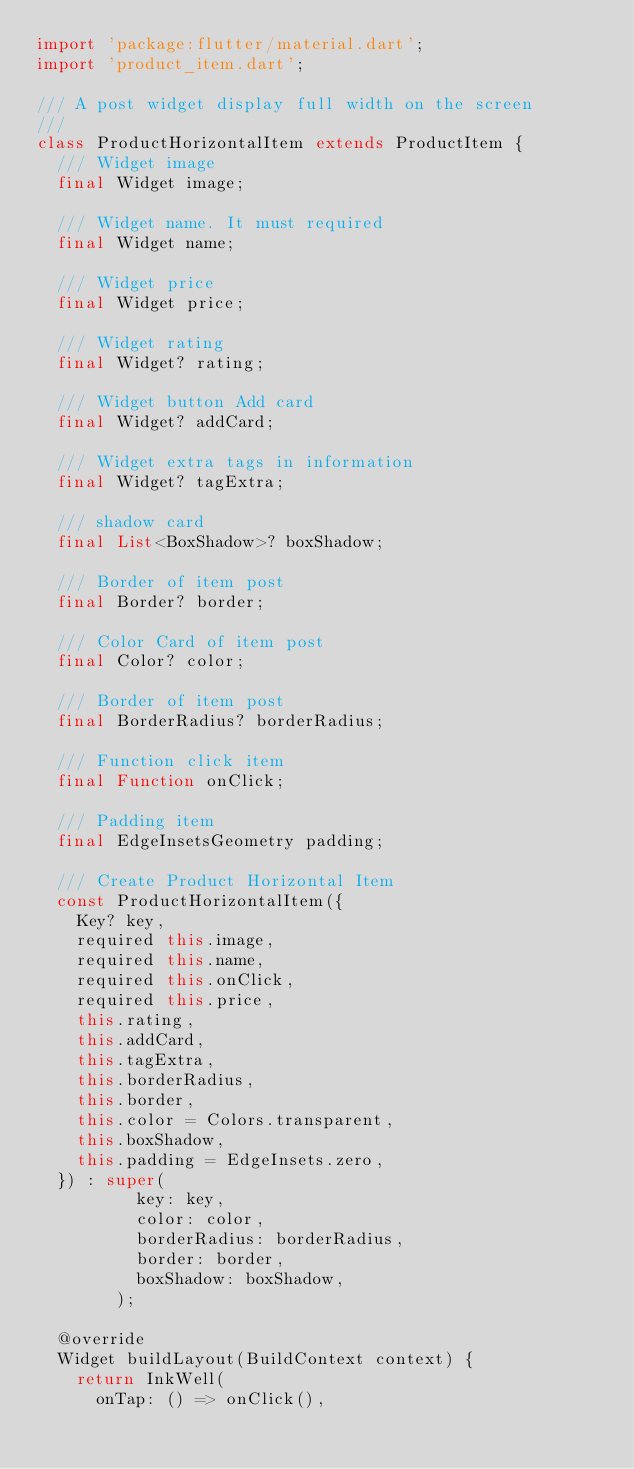<code> <loc_0><loc_0><loc_500><loc_500><_Dart_>import 'package:flutter/material.dart';
import 'product_item.dart';

/// A post widget display full width on the screen
///
class ProductHorizontalItem extends ProductItem {
  /// Widget image
  final Widget image;

  /// Widget name. It must required
  final Widget name;

  /// Widget price
  final Widget price;

  /// Widget rating
  final Widget? rating;

  /// Widget button Add card
  final Widget? addCard;

  /// Widget extra tags in information
  final Widget? tagExtra;

  /// shadow card
  final List<BoxShadow>? boxShadow;

  /// Border of item post
  final Border? border;

  /// Color Card of item post
  final Color? color;

  /// Border of item post
  final BorderRadius? borderRadius;

  /// Function click item
  final Function onClick;

  /// Padding item
  final EdgeInsetsGeometry padding;

  /// Create Product Horizontal Item
  const ProductHorizontalItem({
    Key? key,
    required this.image,
    required this.name,
    required this.onClick,
    required this.price,
    this.rating,
    this.addCard,
    this.tagExtra,
    this.borderRadius,
    this.border,
    this.color = Colors.transparent,
    this.boxShadow,
    this.padding = EdgeInsets.zero,
  }) : super(
          key: key,
          color: color,
          borderRadius: borderRadius,
          border: border,
          boxShadow: boxShadow,
        );

  @override
  Widget buildLayout(BuildContext context) {
    return InkWell(
      onTap: () => onClick(),</code> 